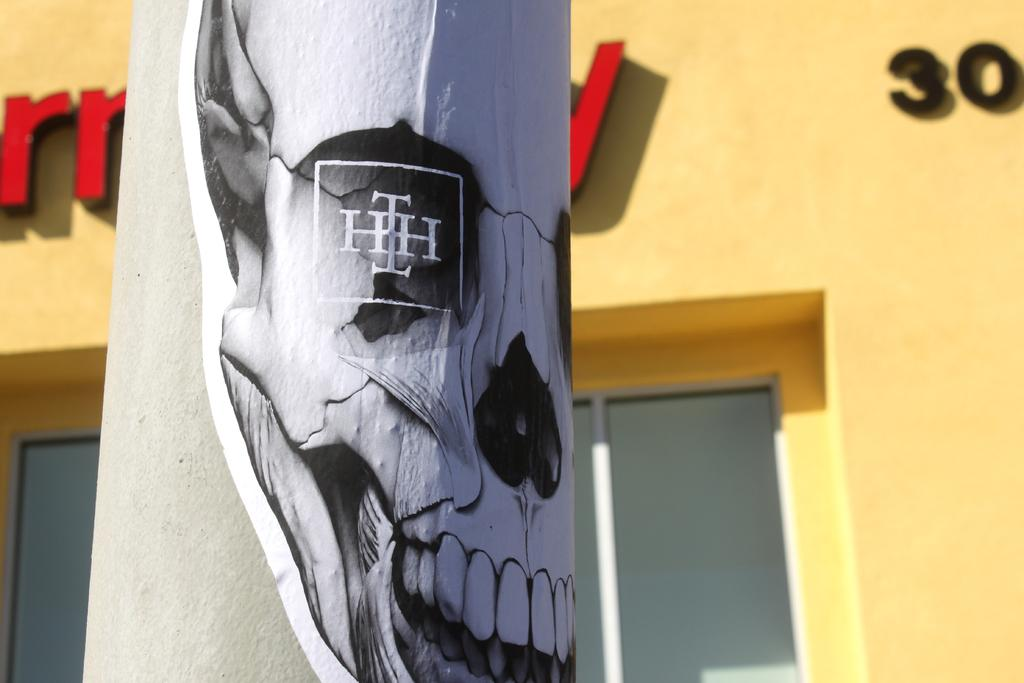What is depicted on the pillar in the image? There is a painting on a pillar in the image. What type of structure can be seen in the image? There is a wall in the image. What architectural feature allows natural light to enter the space? There is a window in the image. What type of fuel is being used to power the learning process in the image? There is no learning process or fuel present in the image; it features a painting on a pillar, a wall, and a window. 